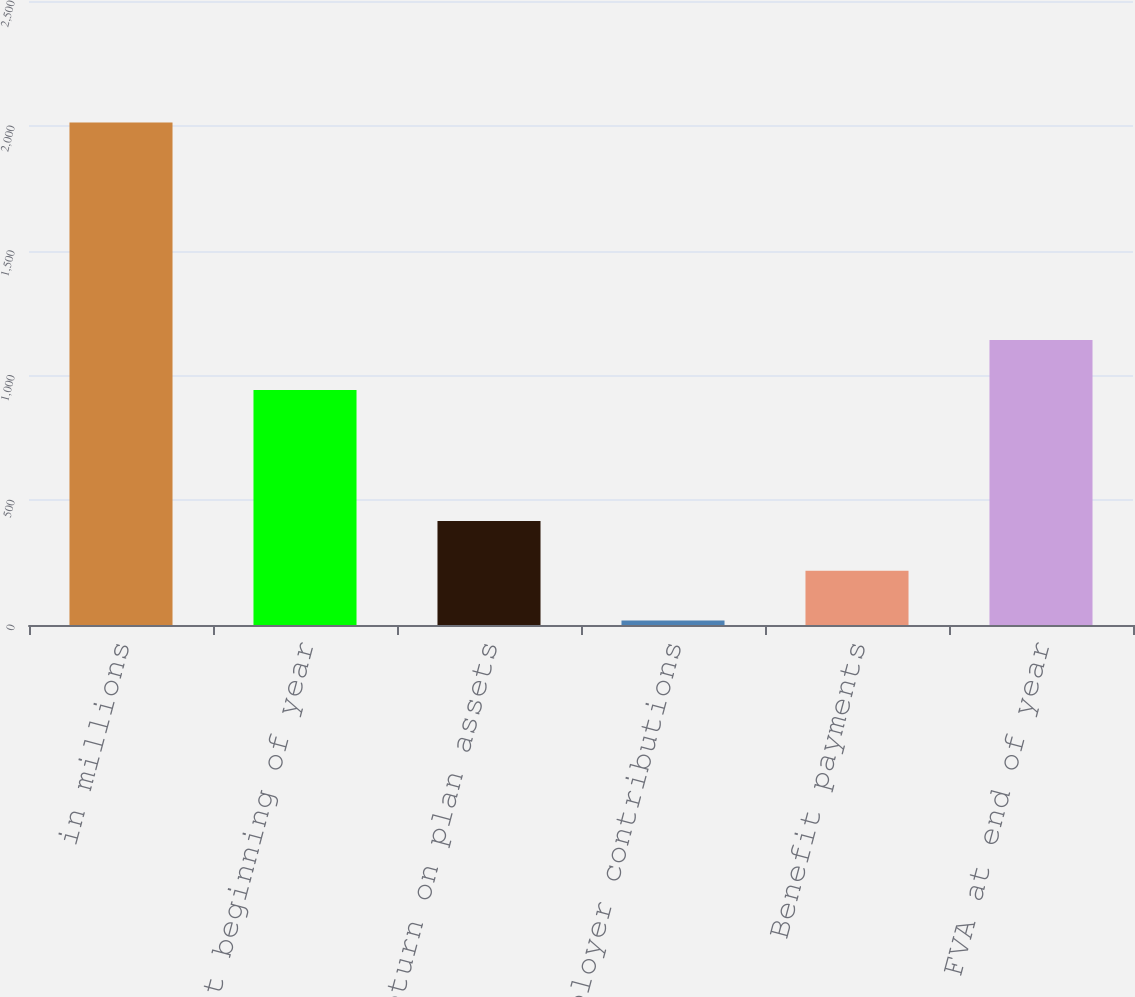Convert chart to OTSL. <chart><loc_0><loc_0><loc_500><loc_500><bar_chart><fcel>in millions<fcel>FVA at beginning of year<fcel>Actual return on plan assets<fcel>Employer contributions<fcel>Benefit payments<fcel>FVA at end of year<nl><fcel>2013<fcel>942<fcel>417<fcel>18<fcel>217.5<fcel>1141.5<nl></chart> 